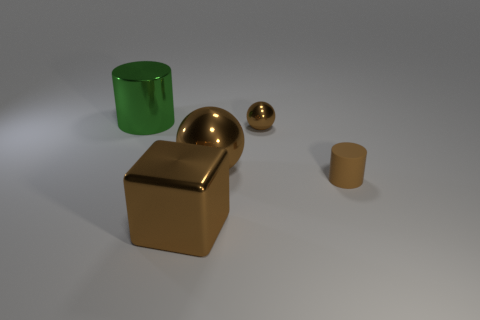How many things are big things that are in front of the tiny metallic sphere or cylinders in front of the large shiny sphere?
Keep it short and to the point. 3. There is a small brown thing in front of the tiny brown ball; is it the same shape as the brown shiny object that is in front of the small brown cylinder?
Your answer should be very brief. No. There is a brown metal thing that is the same size as the brown rubber thing; what shape is it?
Offer a terse response. Sphere. What number of rubber things are blue cylinders or green things?
Provide a succinct answer. 0. Is the cylinder right of the big metal cylinder made of the same material as the cylinder that is behind the matte cylinder?
Offer a terse response. No. There is a big cube that is the same material as the large cylinder; what is its color?
Provide a succinct answer. Brown. Are there more large brown things in front of the metallic cube than small brown shiny balls that are in front of the tiny brown matte cylinder?
Keep it short and to the point. No. Is there a large brown shiny block?
Offer a terse response. Yes. There is a big object that is the same color as the big block; what is it made of?
Your response must be concise. Metal. What number of things are either tiny brown shiny objects or green metal objects?
Your response must be concise. 2. 